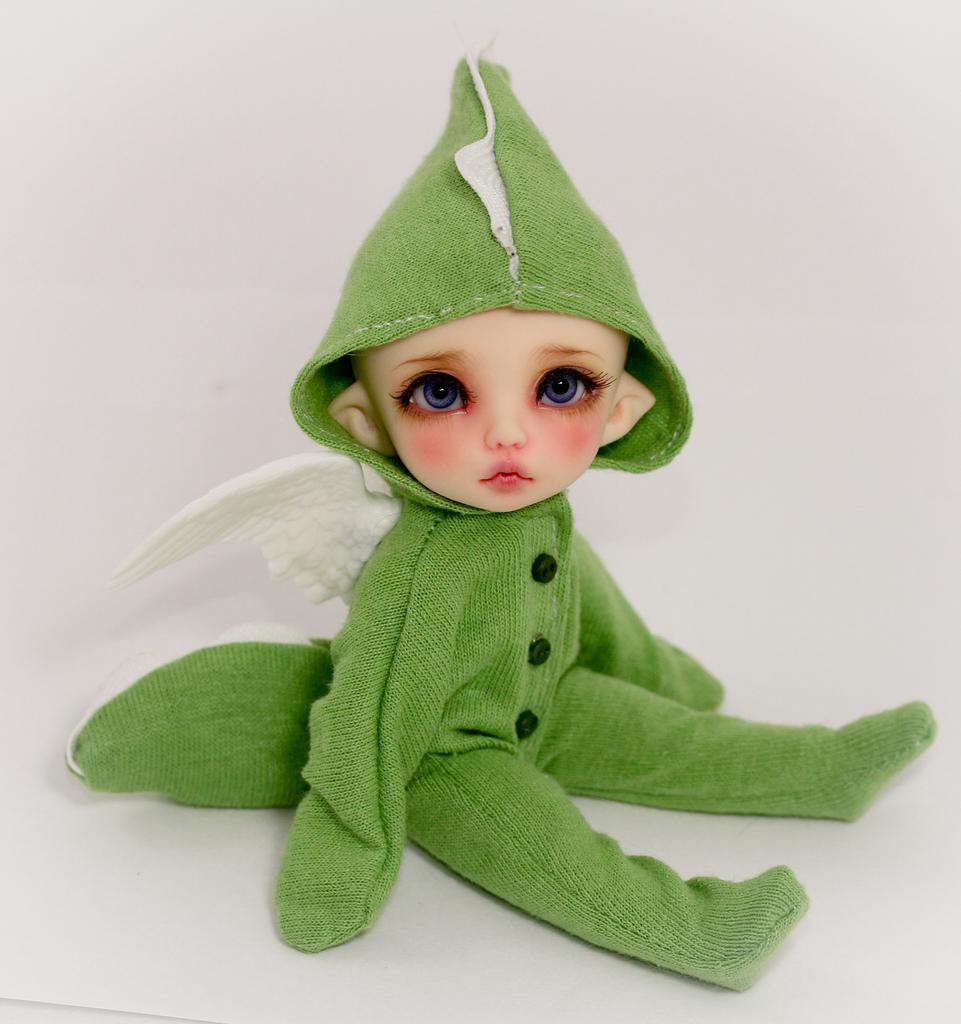Describe this image in one or two sentences. In this image I can see the doll with green and white color dress and I can see the white background. 